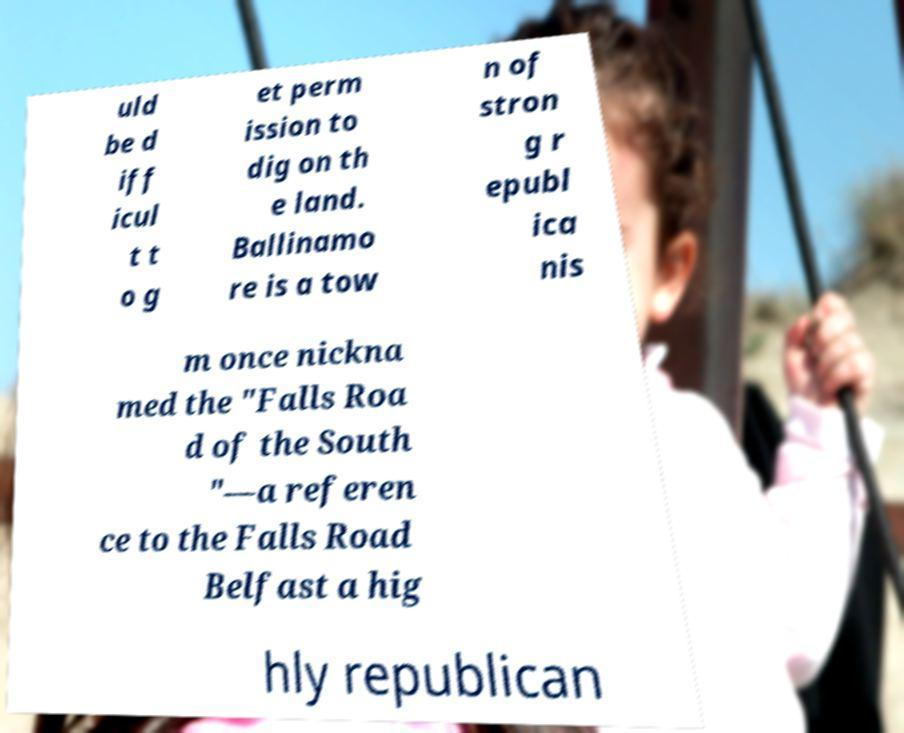Please read and relay the text visible in this image. What does it say? uld be d iff icul t t o g et perm ission to dig on th e land. Ballinamo re is a tow n of stron g r epubl ica nis m once nickna med the "Falls Roa d of the South "—a referen ce to the Falls Road Belfast a hig hly republican 